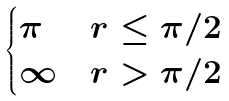<formula> <loc_0><loc_0><loc_500><loc_500>\begin{cases} \pi & r \leq \pi / 2 \\ \infty & r > \pi / 2 \end{cases}</formula> 